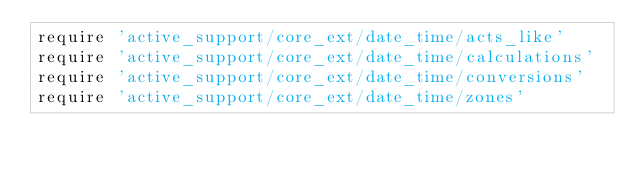Convert code to text. <code><loc_0><loc_0><loc_500><loc_500><_Ruby_>require 'active_support/core_ext/date_time/acts_like'
require 'active_support/core_ext/date_time/calculations'
require 'active_support/core_ext/date_time/conversions'
require 'active_support/core_ext/date_time/zones'
</code> 